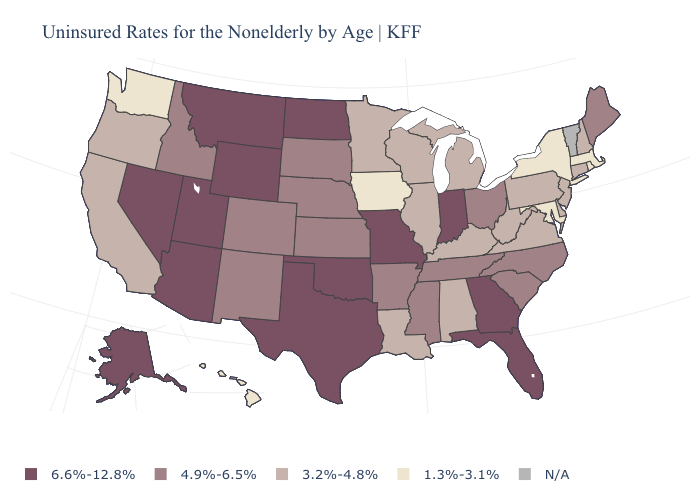What is the value of Pennsylvania?
Quick response, please. 3.2%-4.8%. Name the states that have a value in the range 6.6%-12.8%?
Give a very brief answer. Alaska, Arizona, Florida, Georgia, Indiana, Missouri, Montana, Nevada, North Dakota, Oklahoma, Texas, Utah, Wyoming. Is the legend a continuous bar?
Be succinct. No. Among the states that border Utah , which have the highest value?
Answer briefly. Arizona, Nevada, Wyoming. What is the value of New Mexico?
Keep it brief. 4.9%-6.5%. What is the highest value in the Northeast ?
Be succinct. 4.9%-6.5%. Does Wyoming have the highest value in the USA?
Be succinct. Yes. Does the first symbol in the legend represent the smallest category?
Short answer required. No. What is the value of Tennessee?
Be succinct. 4.9%-6.5%. Does Kentucky have the lowest value in the USA?
Quick response, please. No. What is the lowest value in the USA?
Keep it brief. 1.3%-3.1%. Among the states that border Arizona , does Colorado have the lowest value?
Keep it brief. No. 